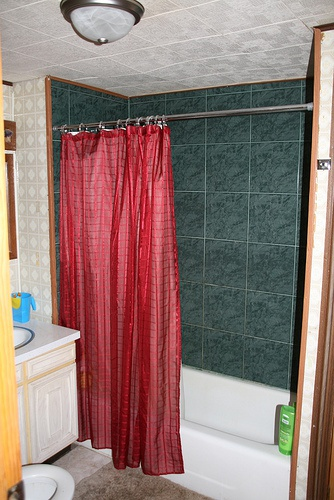Describe the objects in this image and their specific colors. I can see toilet in darkgray, lightgray, gray, and maroon tones, sink in darkgray and lightgray tones, and bottle in darkgray, green, and lightgreen tones in this image. 